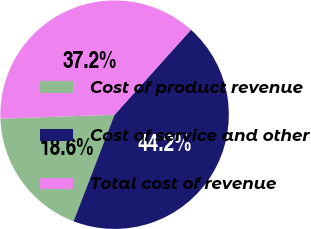Convert chart to OTSL. <chart><loc_0><loc_0><loc_500><loc_500><pie_chart><fcel>Cost of product revenue<fcel>Cost of service and other<fcel>Total cost of revenue<nl><fcel>18.6%<fcel>44.19%<fcel>37.21%<nl></chart> 